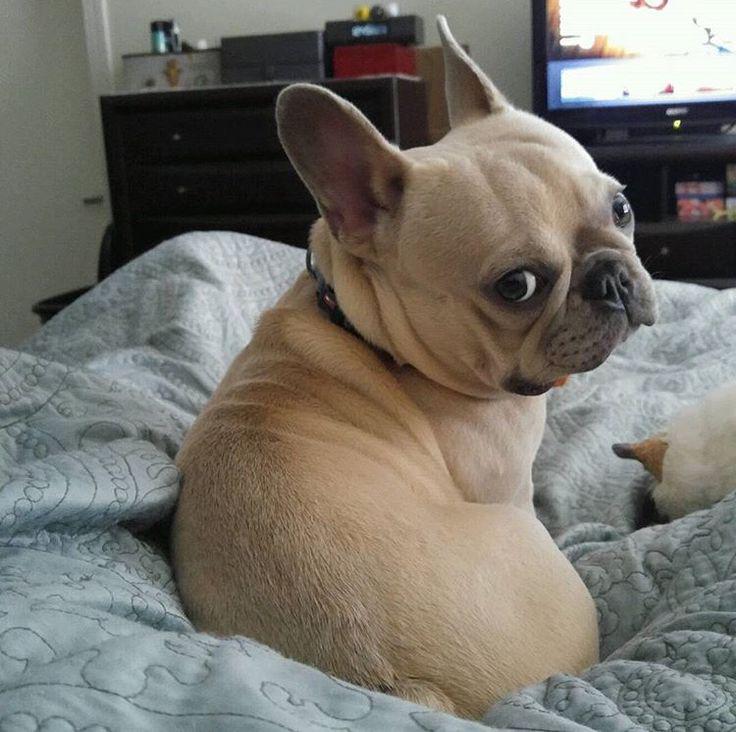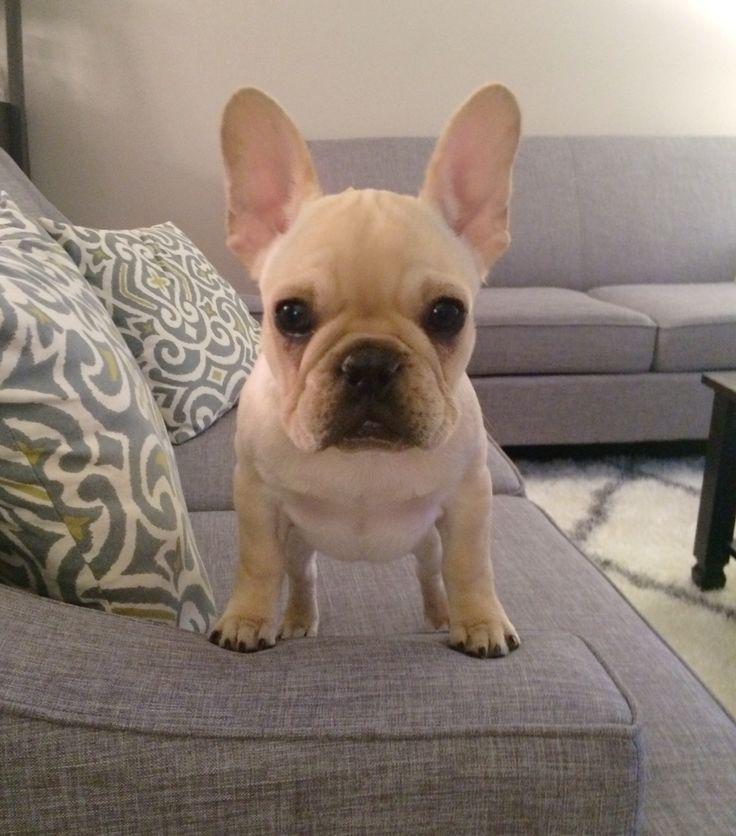The first image is the image on the left, the second image is the image on the right. For the images shown, is this caption "Each image includes one buff-beige bulldog puppy, and the puppy on the left is sitting on fabric, while the puppy on the right is standing on all fours." true? Answer yes or no. Yes. The first image is the image on the left, the second image is the image on the right. Evaluate the accuracy of this statement regarding the images: "None of the dogs pictured are wearing collars.". Is it true? Answer yes or no. No. 